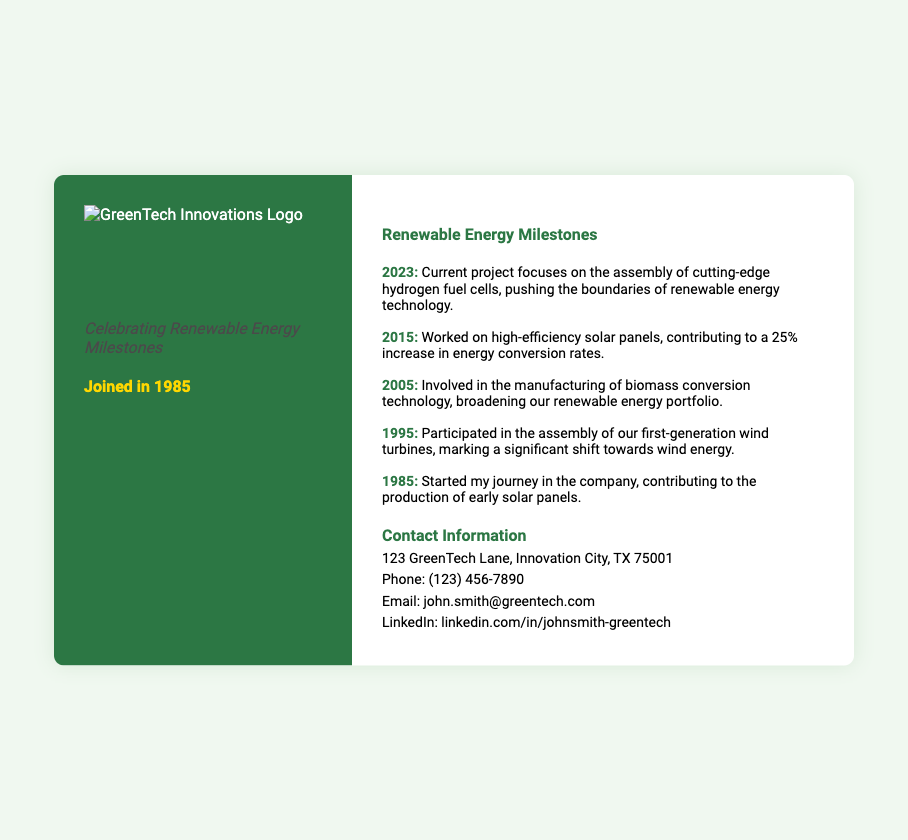what is the name of the individual on the business card? The name of the individual is prominently displayed at the top of the card.
Answer: John Smith what is the title of John Smith? The title is listed under his name, indicating his role within the company.
Answer: Senior Assembly Line Worker what year did John Smith join the company? The year of joining is mentioned under his tagline, reflecting his experience.
Answer: 1985 what is the focus of the current project in 2023? The document highlights the current project being worked on, detailing its main focus.
Answer: hydrogen fuel cells which renewable energy technology did John Smith work on in 2015? This year’s milestone specifies the technology John Smith was involved with.
Answer: solar panels how much increase did high-efficiency solar panels achieve in energy conversion rates? The document explicitly states the percentage increase in conversion rates attributed to the panels.
Answer: 25% what significant shift towards wind energy was noted in 1995? The milestone for this year discusses a major development in renewable energy technology.
Answer: first-generation wind turbines what is the address provided for John Smith? The contact information section contains the address where John Smith can be reached.
Answer: 123 GreenTech Lane, Innovation City, TX 75001 what social media platform is mentioned for John Smith? The contact information section includes a specific platform where a professional profile can be found.
Answer: LinkedIn 